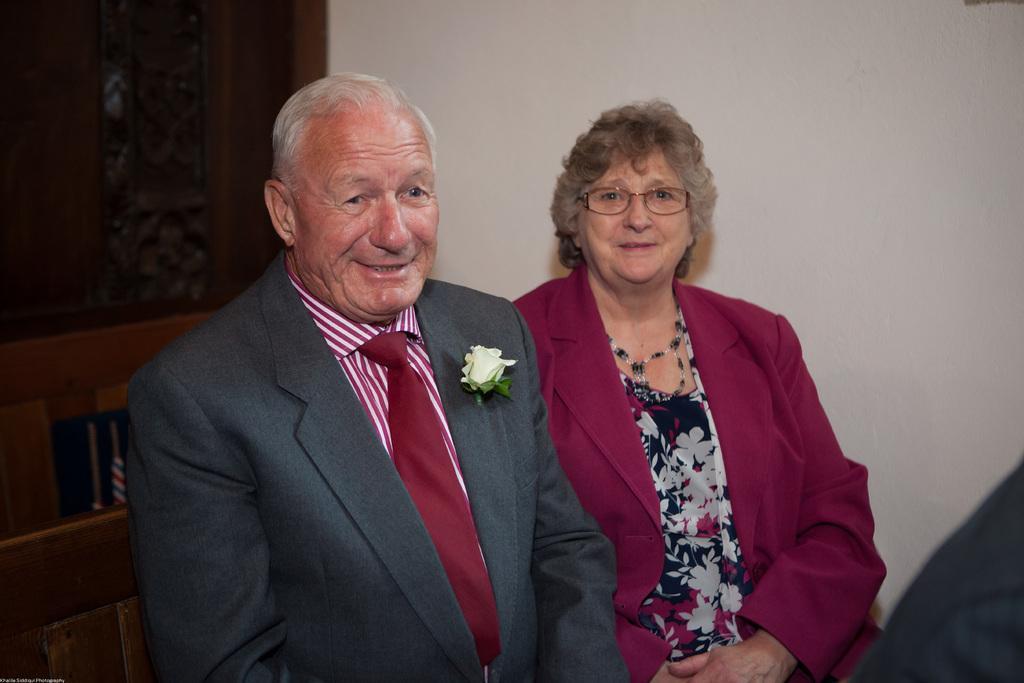Please provide a concise description of this image. In front of the image there are people. Behind them there is a wall. On the left side of the image there are carvings on the wooden board. There is some text at the bottom of the image. 